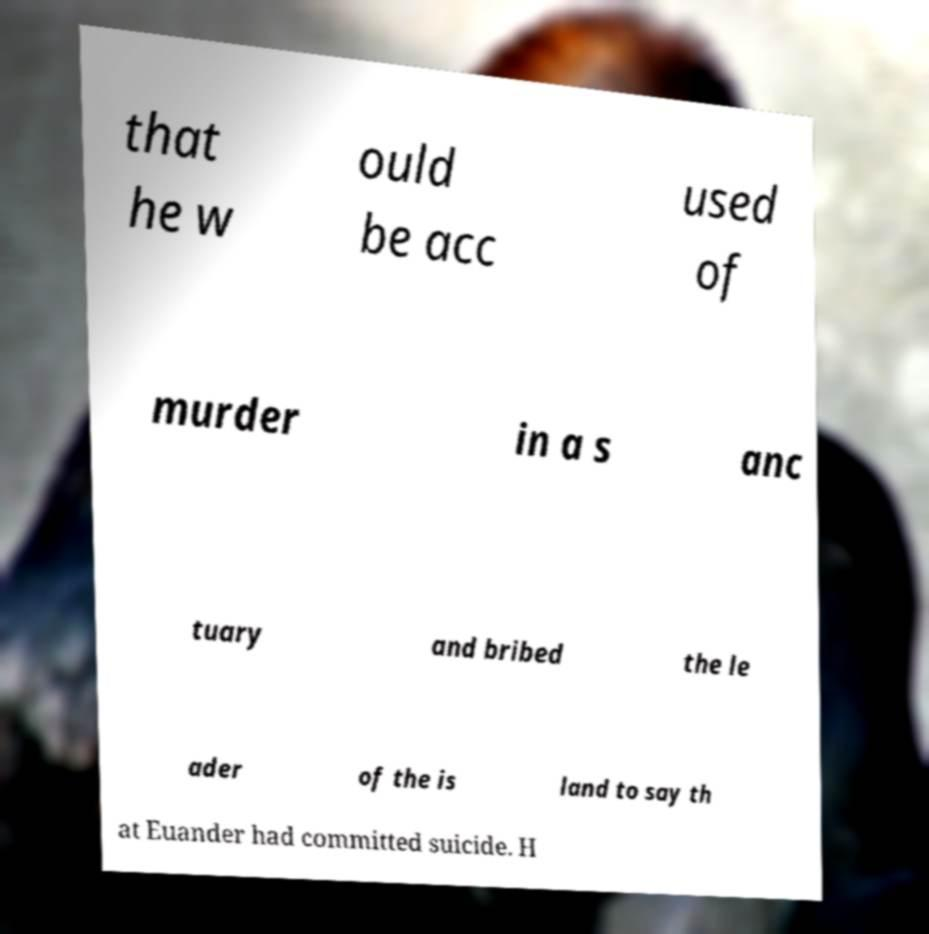Can you read and provide the text displayed in the image?This photo seems to have some interesting text. Can you extract and type it out for me? that he w ould be acc used of murder in a s anc tuary and bribed the le ader of the is land to say th at Euander had committed suicide. H 